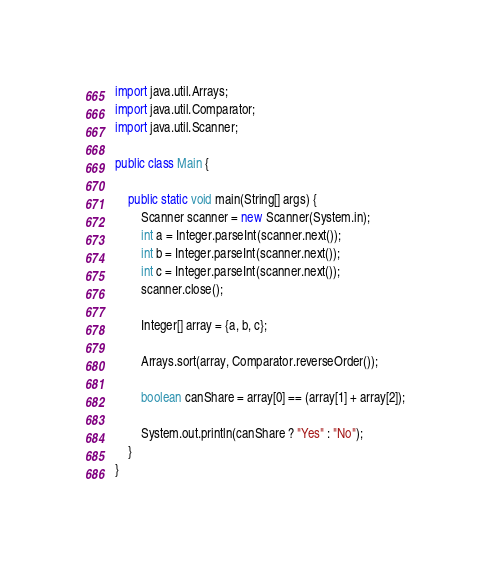<code> <loc_0><loc_0><loc_500><loc_500><_Java_>import java.util.Arrays;
import java.util.Comparator;
import java.util.Scanner;

public class Main {

    public static void main(String[] args) {
        Scanner scanner = new Scanner(System.in);
        int a = Integer.parseInt(scanner.next());
        int b = Integer.parseInt(scanner.next());
        int c = Integer.parseInt(scanner.next());
        scanner.close();

        Integer[] array = {a, b, c};

        Arrays.sort(array, Comparator.reverseOrder());

        boolean canShare = array[0] == (array[1] + array[2]);

        System.out.println(canShare ? "Yes" : "No");
    }
}
</code> 